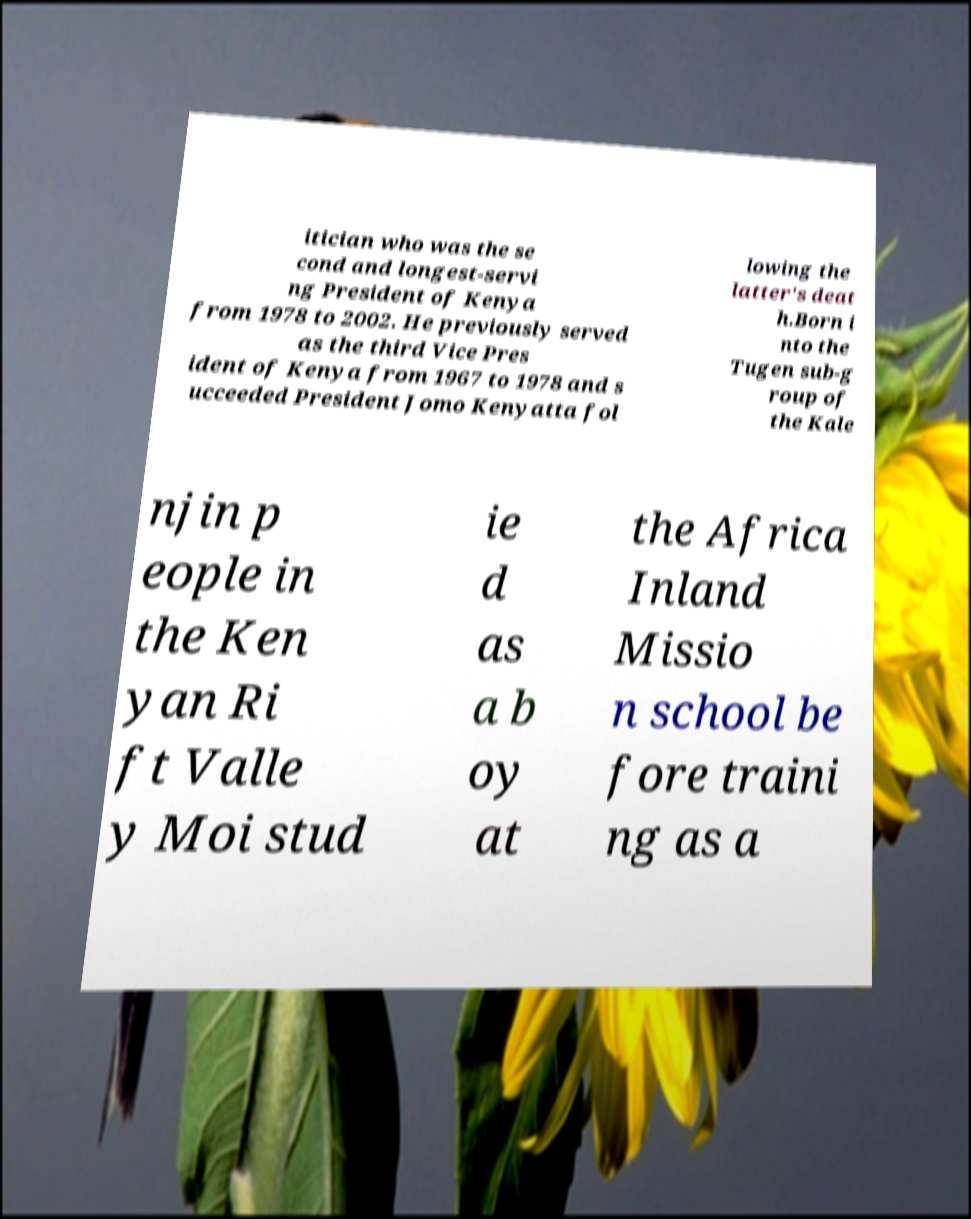For documentation purposes, I need the text within this image transcribed. Could you provide that? itician who was the se cond and longest-servi ng President of Kenya from 1978 to 2002. He previously served as the third Vice Pres ident of Kenya from 1967 to 1978 and s ucceeded President Jomo Kenyatta fol lowing the latter's deat h.Born i nto the Tugen sub-g roup of the Kale njin p eople in the Ken yan Ri ft Valle y Moi stud ie d as a b oy at the Africa Inland Missio n school be fore traini ng as a 